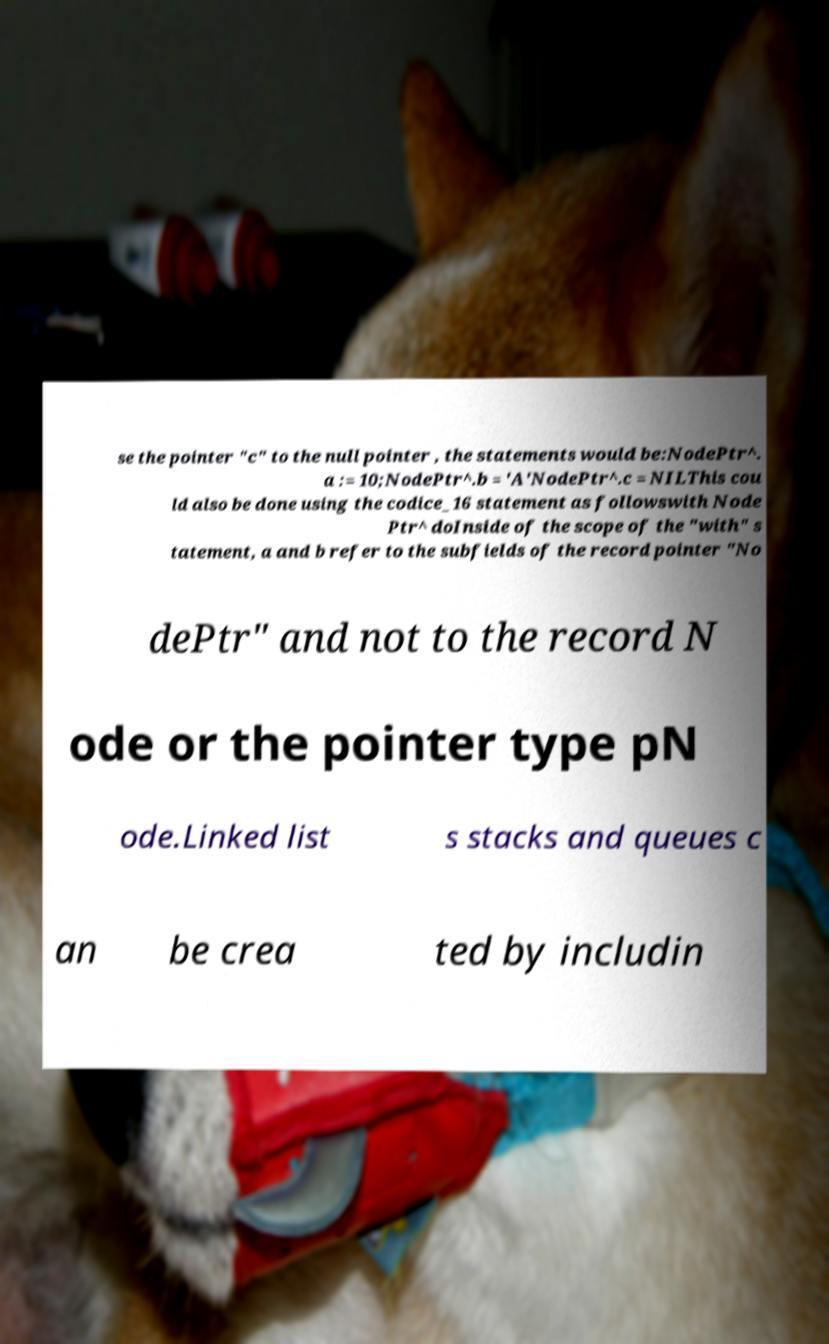Could you extract and type out the text from this image? se the pointer "c" to the null pointer , the statements would be:NodePtr^. a := 10;NodePtr^.b = 'A'NodePtr^.c = NILThis cou ld also be done using the codice_16 statement as followswith Node Ptr^ doInside of the scope of the "with" s tatement, a and b refer to the subfields of the record pointer "No dePtr" and not to the record N ode or the pointer type pN ode.Linked list s stacks and queues c an be crea ted by includin 